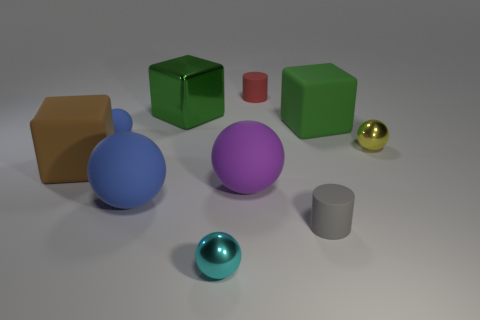Can you describe the lighting and shadow effects in the image? In the image, the lighting appears to be soft and diffused, with likely a single light source located above and slightly to the right, as shown by the positioning of the shadows. Each object casts a distinct shadow to the left and slightly downward, consistent with the light direction. The shadows' soft edges indicate that the light source is not close to the objects, providing a gentle illumination without harsh contrasts. This setup gives the scene a calm and balanced atmosphere. 